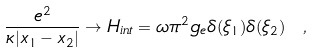<formula> <loc_0><loc_0><loc_500><loc_500>\frac { e ^ { 2 } } { \kappa | x _ { 1 } - x _ { 2 } | } \to H _ { i n t } = \omega \pi ^ { 2 } g _ { e } \delta ( \xi _ { 1 } ) \delta ( \xi _ { 2 } ) \ ,</formula> 